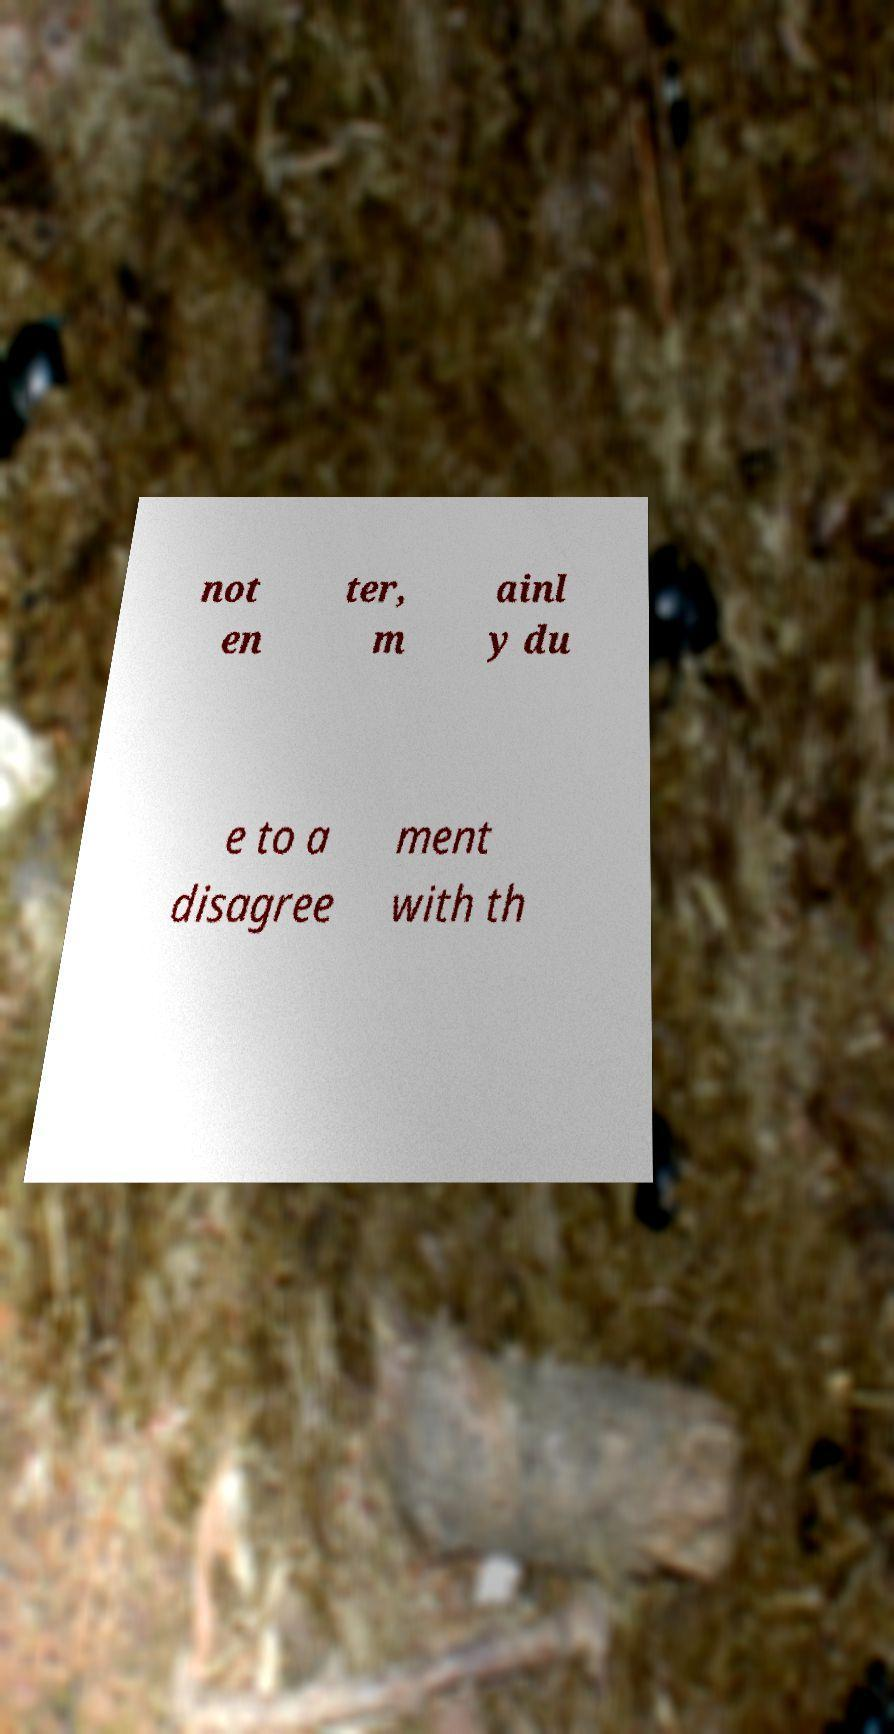Please read and relay the text visible in this image. What does it say? not en ter, m ainl y du e to a disagree ment with th 